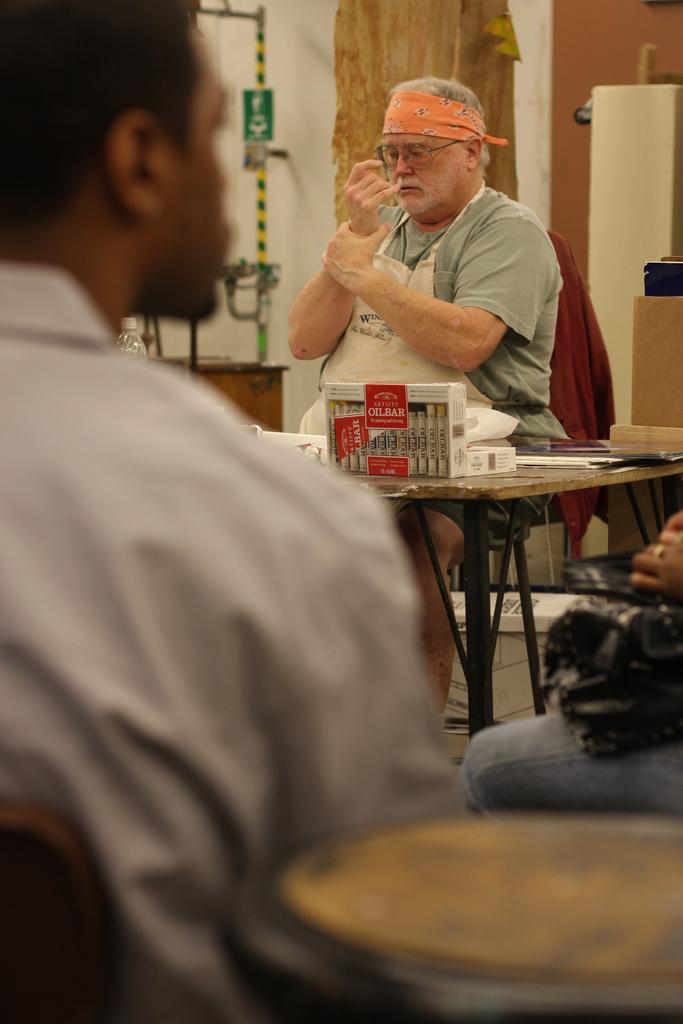How many people are sitting in the image? There are two men sitting in the image. What object can be seen in the image that is typically used for storage or transportation? There is a box in the image. What is on the table in the image? There is a paper on a table in the image. What vertical structure can be seen in the image? There is a pole in the image. What type of architectural feature is present in the image? There is a wall in the image. What type of zephyr is sitting on the throne in the image? There is no zephyr or throne present in the image. What type of muscle is visible on the man in the image? The image does not provide enough detail to identify specific muscles on the man. 